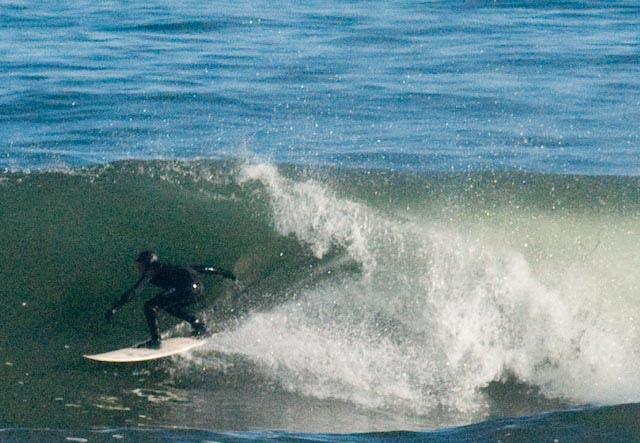How many trains are there?
Give a very brief answer. 0. 